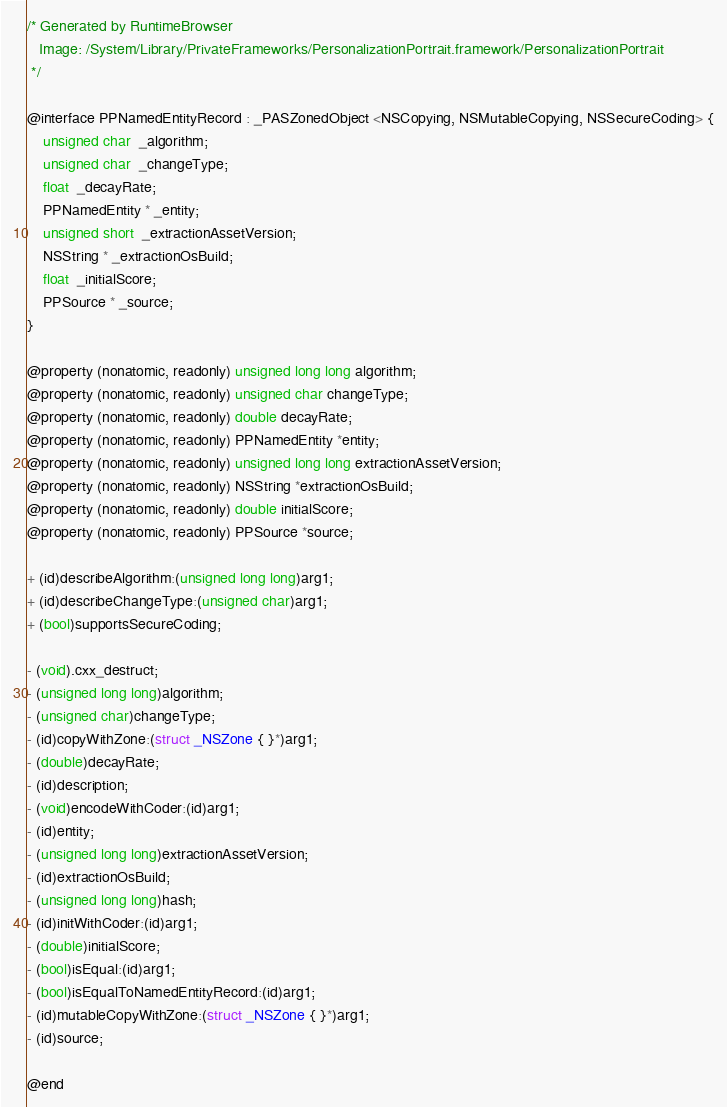<code> <loc_0><loc_0><loc_500><loc_500><_C_>/* Generated by RuntimeBrowser
   Image: /System/Library/PrivateFrameworks/PersonalizationPortrait.framework/PersonalizationPortrait
 */

@interface PPNamedEntityRecord : _PASZonedObject <NSCopying, NSMutableCopying, NSSecureCoding> {
    unsigned char  _algorithm;
    unsigned char  _changeType;
    float  _decayRate;
    PPNamedEntity * _entity;
    unsigned short  _extractionAssetVersion;
    NSString * _extractionOsBuild;
    float  _initialScore;
    PPSource * _source;
}

@property (nonatomic, readonly) unsigned long long algorithm;
@property (nonatomic, readonly) unsigned char changeType;
@property (nonatomic, readonly) double decayRate;
@property (nonatomic, readonly) PPNamedEntity *entity;
@property (nonatomic, readonly) unsigned long long extractionAssetVersion;
@property (nonatomic, readonly) NSString *extractionOsBuild;
@property (nonatomic, readonly) double initialScore;
@property (nonatomic, readonly) PPSource *source;

+ (id)describeAlgorithm:(unsigned long long)arg1;
+ (id)describeChangeType:(unsigned char)arg1;
+ (bool)supportsSecureCoding;

- (void).cxx_destruct;
- (unsigned long long)algorithm;
- (unsigned char)changeType;
- (id)copyWithZone:(struct _NSZone { }*)arg1;
- (double)decayRate;
- (id)description;
- (void)encodeWithCoder:(id)arg1;
- (id)entity;
- (unsigned long long)extractionAssetVersion;
- (id)extractionOsBuild;
- (unsigned long long)hash;
- (id)initWithCoder:(id)arg1;
- (double)initialScore;
- (bool)isEqual:(id)arg1;
- (bool)isEqualToNamedEntityRecord:(id)arg1;
- (id)mutableCopyWithZone:(struct _NSZone { }*)arg1;
- (id)source;

@end
</code> 